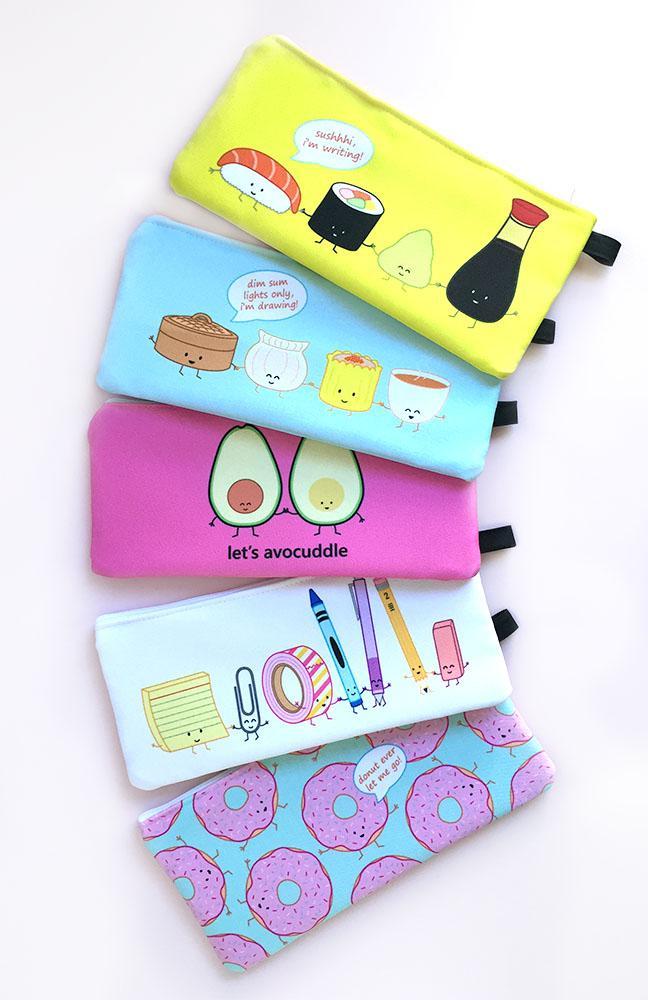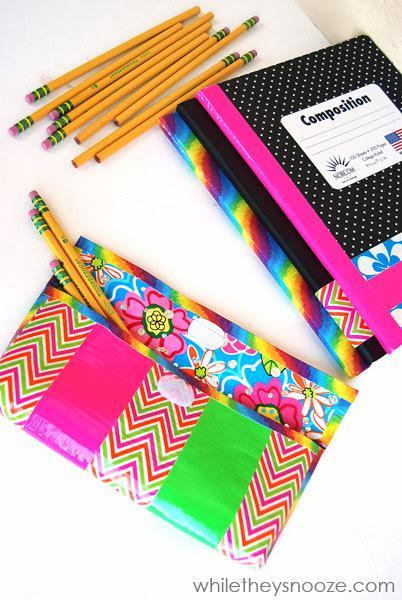The first image is the image on the left, the second image is the image on the right. Evaluate the accuracy of this statement regarding the images: "In one of the images, three pencils are sticking out of the front pocket on the pencil case.". Is it true? Answer yes or no. Yes. The first image is the image on the left, the second image is the image on the right. Given the left and right images, does the statement "An image includes a flat case with a zig-zag pattern and yellow pencils sticking out of its front pocket." hold true? Answer yes or no. Yes. The first image is the image on the left, the second image is the image on the right. Evaluate the accuracy of this statement regarding the images: "There are two pencil cases in the image on the right.". Is it true? Answer yes or no. Yes. 